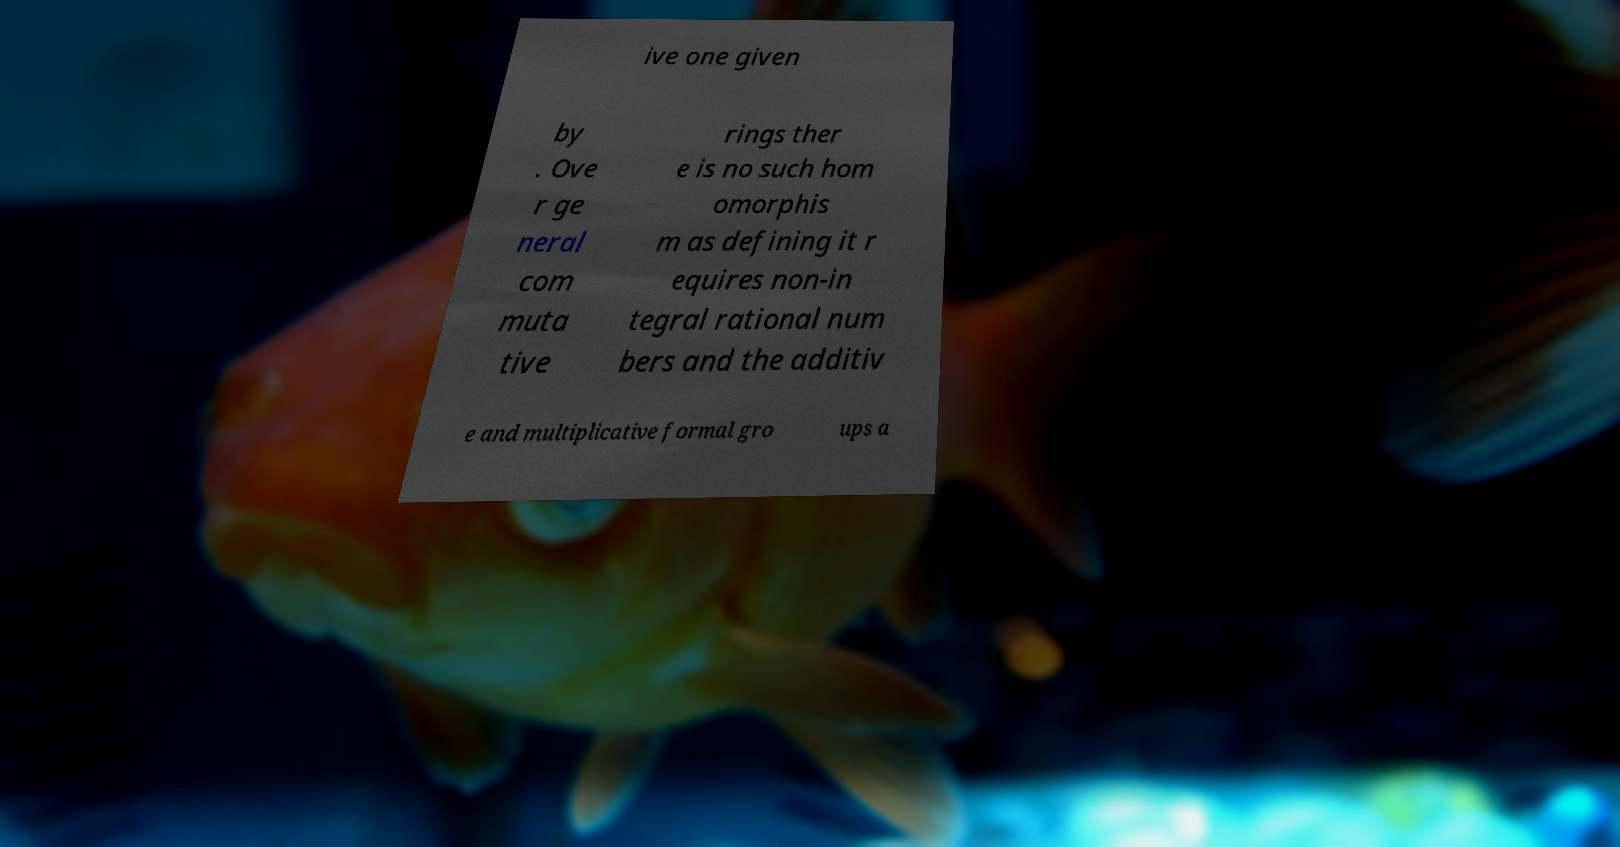Could you extract and type out the text from this image? ive one given by . Ove r ge neral com muta tive rings ther e is no such hom omorphis m as defining it r equires non-in tegral rational num bers and the additiv e and multiplicative formal gro ups a 